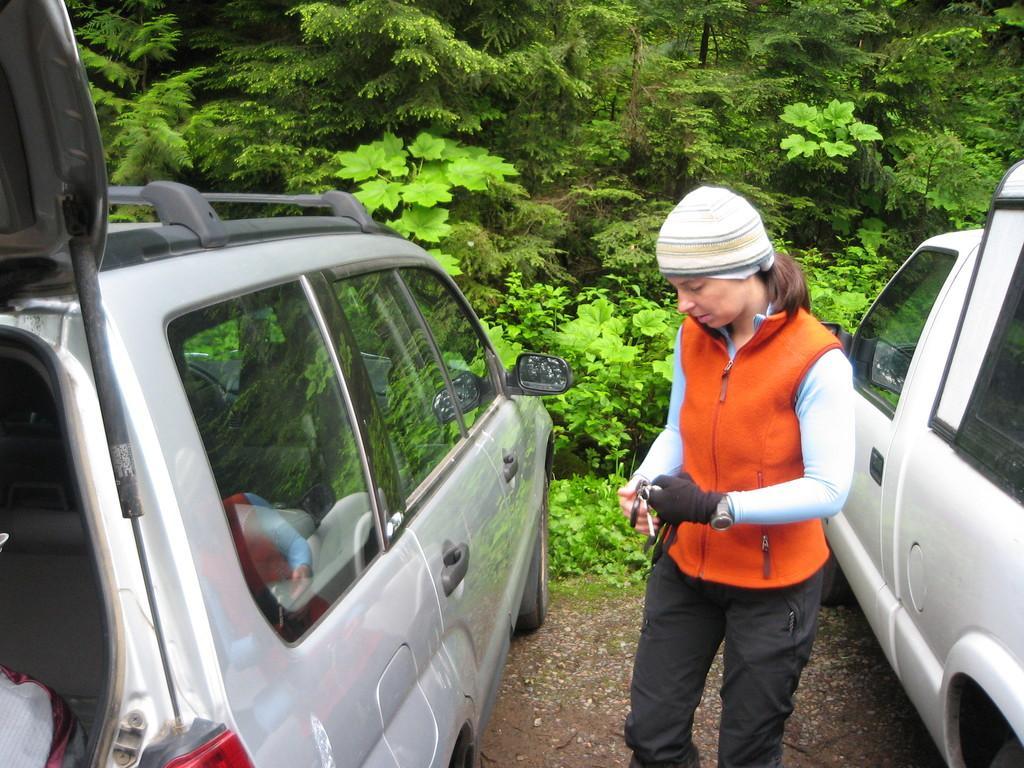Describe this image in one or two sentences. In this image in the front there is a woman standing and there are cars. In the background there are trees. 